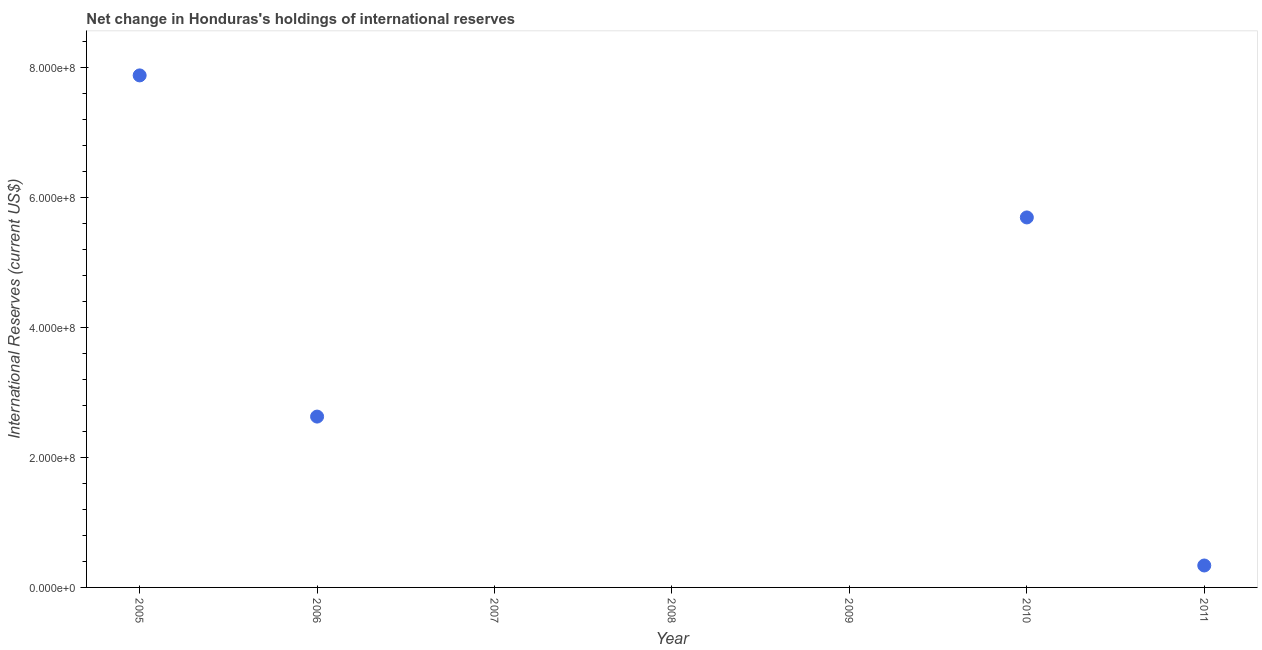Across all years, what is the maximum reserves and related items?
Make the answer very short. 7.88e+08. Across all years, what is the minimum reserves and related items?
Ensure brevity in your answer.  0. In which year was the reserves and related items maximum?
Provide a succinct answer. 2005. What is the sum of the reserves and related items?
Your answer should be compact. 1.65e+09. What is the difference between the reserves and related items in 2006 and 2011?
Make the answer very short. 2.29e+08. What is the average reserves and related items per year?
Offer a terse response. 2.36e+08. What is the median reserves and related items?
Offer a very short reply. 3.38e+07. In how many years, is the reserves and related items greater than 200000000 US$?
Offer a terse response. 3. What is the ratio of the reserves and related items in 2005 to that in 2011?
Offer a terse response. 23.34. What is the difference between the highest and the second highest reserves and related items?
Ensure brevity in your answer.  2.19e+08. What is the difference between the highest and the lowest reserves and related items?
Your answer should be compact. 7.88e+08. In how many years, is the reserves and related items greater than the average reserves and related items taken over all years?
Your answer should be very brief. 3. How many dotlines are there?
Offer a terse response. 1. What is the difference between two consecutive major ticks on the Y-axis?
Your response must be concise. 2.00e+08. Are the values on the major ticks of Y-axis written in scientific E-notation?
Provide a succinct answer. Yes. What is the title of the graph?
Offer a very short reply. Net change in Honduras's holdings of international reserves. What is the label or title of the X-axis?
Provide a succinct answer. Year. What is the label or title of the Y-axis?
Your answer should be compact. International Reserves (current US$). What is the International Reserves (current US$) in 2005?
Give a very brief answer. 7.88e+08. What is the International Reserves (current US$) in 2006?
Ensure brevity in your answer.  2.63e+08. What is the International Reserves (current US$) in 2007?
Make the answer very short. 0. What is the International Reserves (current US$) in 2010?
Your answer should be compact. 5.70e+08. What is the International Reserves (current US$) in 2011?
Give a very brief answer. 3.38e+07. What is the difference between the International Reserves (current US$) in 2005 and 2006?
Ensure brevity in your answer.  5.25e+08. What is the difference between the International Reserves (current US$) in 2005 and 2010?
Make the answer very short. 2.19e+08. What is the difference between the International Reserves (current US$) in 2005 and 2011?
Your answer should be very brief. 7.54e+08. What is the difference between the International Reserves (current US$) in 2006 and 2010?
Your answer should be compact. -3.07e+08. What is the difference between the International Reserves (current US$) in 2006 and 2011?
Keep it short and to the point. 2.29e+08. What is the difference between the International Reserves (current US$) in 2010 and 2011?
Your response must be concise. 5.36e+08. What is the ratio of the International Reserves (current US$) in 2005 to that in 2006?
Your answer should be very brief. 3. What is the ratio of the International Reserves (current US$) in 2005 to that in 2010?
Your response must be concise. 1.38. What is the ratio of the International Reserves (current US$) in 2005 to that in 2011?
Ensure brevity in your answer.  23.34. What is the ratio of the International Reserves (current US$) in 2006 to that in 2010?
Make the answer very short. 0.46. What is the ratio of the International Reserves (current US$) in 2006 to that in 2011?
Your answer should be very brief. 7.79. What is the ratio of the International Reserves (current US$) in 2010 to that in 2011?
Provide a short and direct response. 16.87. 